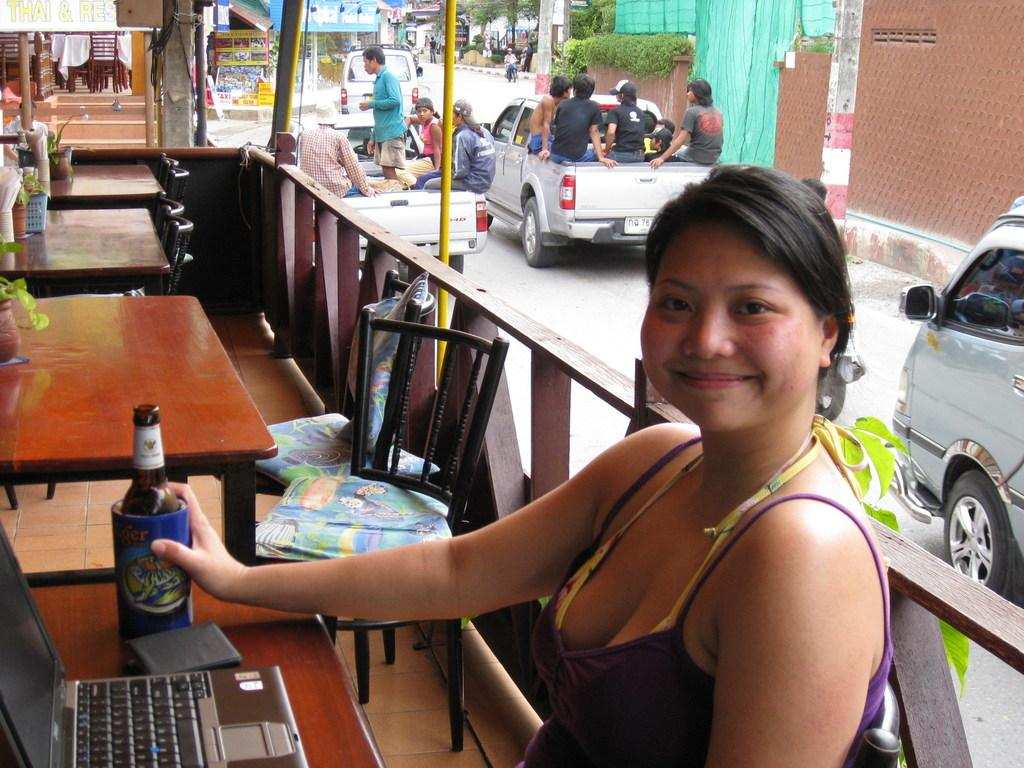Who is the main subject in the image? There is a woman in the image. What is the woman doing in the image? The woman is sitting on a chair. What objects are on the table in the image? There is a laptop and a wine bottle on the table. What can be seen in the background of the image? People are sitting on a car in the background. How many cherries are on the woman's plate in the image? There is no plate or cherries present in the image. What question is the woman asking in the image? There is no indication of the woman asking a question in the image. 